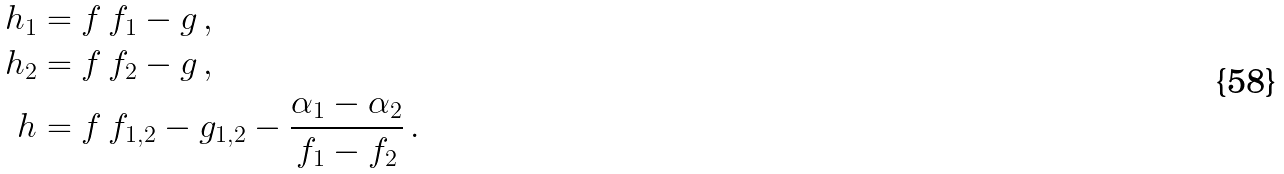Convert formula to latex. <formula><loc_0><loc_0><loc_500><loc_500>h _ { 1 } & = f \, f _ { 1 } - g \, , \\ h _ { 2 } & = f \, f _ { 2 } - g \, , \\ h & = f \, f _ { 1 , 2 } - g _ { 1 , 2 } - \frac { \alpha _ { 1 } - \alpha _ { 2 } } { f _ { 1 } - f _ { 2 } } \, .</formula> 